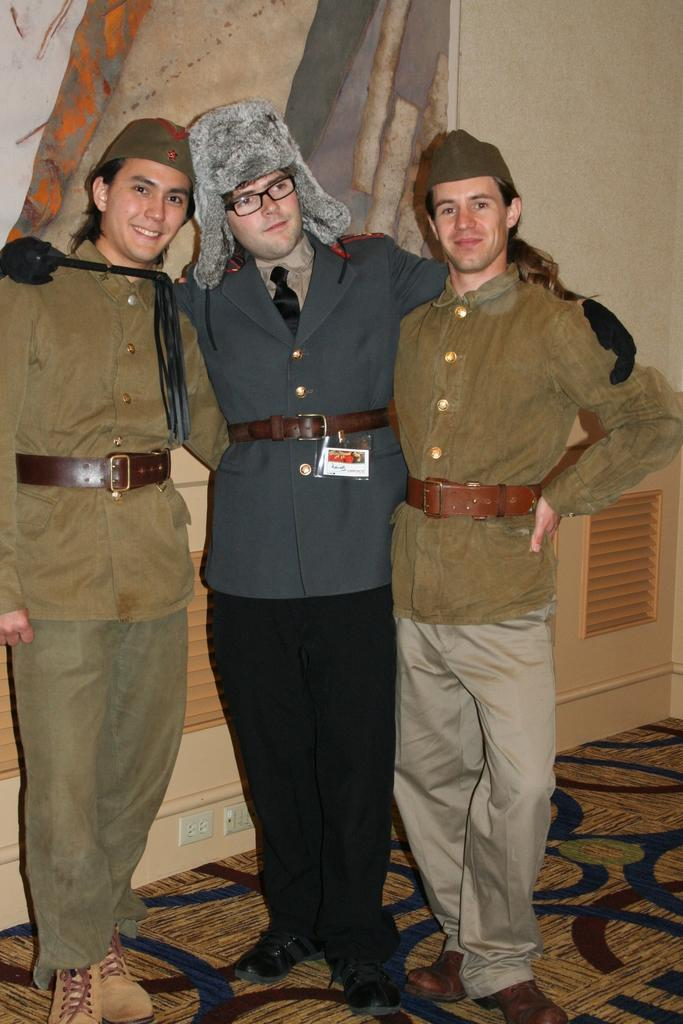How many people are present in the image? There are three people in the image. What are the people doing in the image? The people are standing in the image. What expressions do the people have in the image? The people are smiling in the image. What can be seen on the wall in the background of the image? There is a painting on the wall in the background. How many snakes are wrapped around the people's hair in the image? There are no snakes present in the image, and the people's hair is not mentioned. What type of muscle is visible on the people's arms in the image? There is no specific muscle mentioned or visible in the image; the people are simply standing and smiling. 